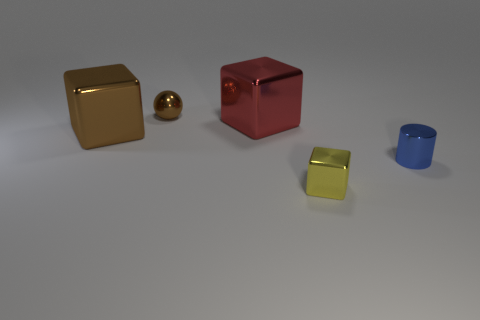Is there a small blue cylinder that has the same material as the tiny sphere?
Keep it short and to the point. Yes. The brown object that is on the right side of the big object in front of the big metallic object that is to the right of the small sphere is what shape?
Ensure brevity in your answer.  Sphere. There is a large metal thing that is in front of the big red block; does it have the same color as the tiny thing on the left side of the tiny yellow thing?
Your answer should be compact. Yes. Is there any other thing that has the same size as the ball?
Give a very brief answer. Yes. Are there any big objects in front of the tiny metal cube?
Offer a very short reply. No. What number of blue objects have the same shape as the tiny yellow thing?
Offer a terse response. 0. There is a small object right of the metallic object that is in front of the small metal thing right of the small yellow block; what color is it?
Offer a very short reply. Blue. Is the material of the block in front of the big brown object the same as the small object left of the small yellow metallic thing?
Give a very brief answer. Yes. How many things are either small metallic objects that are behind the small yellow object or large red rubber cylinders?
Provide a succinct answer. 2. How many things are either small brown metal spheres or metal blocks in front of the big red metallic thing?
Keep it short and to the point. 3. 